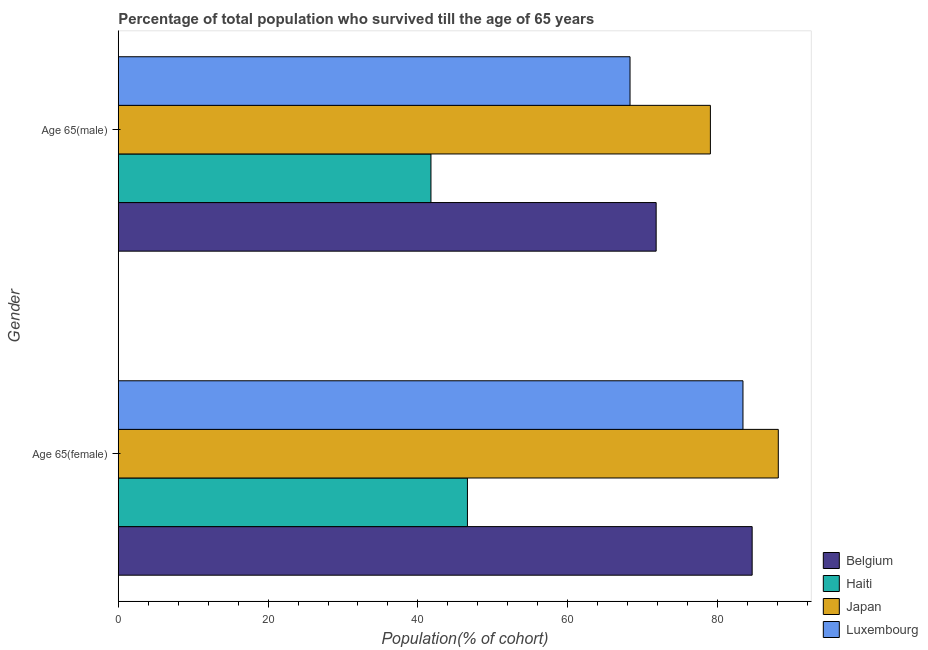How many groups of bars are there?
Your answer should be compact. 2. Are the number of bars per tick equal to the number of legend labels?
Provide a succinct answer. Yes. Are the number of bars on each tick of the Y-axis equal?
Your answer should be very brief. Yes. How many bars are there on the 1st tick from the top?
Your answer should be compact. 4. What is the label of the 2nd group of bars from the top?
Ensure brevity in your answer.  Age 65(female). What is the percentage of female population who survived till age of 65 in Belgium?
Your answer should be compact. 84.63. Across all countries, what is the maximum percentage of male population who survived till age of 65?
Your response must be concise. 79.05. Across all countries, what is the minimum percentage of male population who survived till age of 65?
Provide a succinct answer. 41.74. In which country was the percentage of male population who survived till age of 65 minimum?
Make the answer very short. Haiti. What is the total percentage of female population who survived till age of 65 in the graph?
Your response must be concise. 302.76. What is the difference between the percentage of female population who survived till age of 65 in Haiti and that in Belgium?
Offer a very short reply. -38.01. What is the difference between the percentage of female population who survived till age of 65 in Japan and the percentage of male population who survived till age of 65 in Haiti?
Make the answer very short. 46.37. What is the average percentage of female population who survived till age of 65 per country?
Your response must be concise. 75.69. What is the difference between the percentage of female population who survived till age of 65 and percentage of male population who survived till age of 65 in Belgium?
Keep it short and to the point. 12.82. In how many countries, is the percentage of female population who survived till age of 65 greater than 64 %?
Your answer should be very brief. 3. What is the ratio of the percentage of male population who survived till age of 65 in Belgium to that in Luxembourg?
Make the answer very short. 1.05. Is the percentage of female population who survived till age of 65 in Belgium less than that in Haiti?
Make the answer very short. No. In how many countries, is the percentage of female population who survived till age of 65 greater than the average percentage of female population who survived till age of 65 taken over all countries?
Offer a terse response. 3. What does the 3rd bar from the top in Age 65(male) represents?
Provide a short and direct response. Haiti. What does the 4th bar from the bottom in Age 65(female) represents?
Offer a very short reply. Luxembourg. How many bars are there?
Offer a terse response. 8. Are all the bars in the graph horizontal?
Offer a terse response. Yes. What is the difference between two consecutive major ticks on the X-axis?
Give a very brief answer. 20. Are the values on the major ticks of X-axis written in scientific E-notation?
Provide a succinct answer. No. How many legend labels are there?
Ensure brevity in your answer.  4. How are the legend labels stacked?
Offer a very short reply. Vertical. What is the title of the graph?
Give a very brief answer. Percentage of total population who survived till the age of 65 years. Does "Mauritius" appear as one of the legend labels in the graph?
Make the answer very short. No. What is the label or title of the X-axis?
Your answer should be compact. Population(% of cohort). What is the Population(% of cohort) in Belgium in Age 65(female)?
Your answer should be very brief. 84.63. What is the Population(% of cohort) of Haiti in Age 65(female)?
Offer a very short reply. 46.61. What is the Population(% of cohort) in Japan in Age 65(female)?
Your answer should be compact. 88.12. What is the Population(% of cohort) of Luxembourg in Age 65(female)?
Make the answer very short. 83.4. What is the Population(% of cohort) in Belgium in Age 65(male)?
Offer a terse response. 71.81. What is the Population(% of cohort) in Haiti in Age 65(male)?
Offer a very short reply. 41.74. What is the Population(% of cohort) of Japan in Age 65(male)?
Keep it short and to the point. 79.05. What is the Population(% of cohort) of Luxembourg in Age 65(male)?
Give a very brief answer. 68.32. Across all Gender, what is the maximum Population(% of cohort) in Belgium?
Your answer should be very brief. 84.63. Across all Gender, what is the maximum Population(% of cohort) of Haiti?
Make the answer very short. 46.61. Across all Gender, what is the maximum Population(% of cohort) in Japan?
Offer a very short reply. 88.12. Across all Gender, what is the maximum Population(% of cohort) in Luxembourg?
Keep it short and to the point. 83.4. Across all Gender, what is the minimum Population(% of cohort) in Belgium?
Give a very brief answer. 71.81. Across all Gender, what is the minimum Population(% of cohort) of Haiti?
Provide a short and direct response. 41.74. Across all Gender, what is the minimum Population(% of cohort) of Japan?
Your answer should be compact. 79.05. Across all Gender, what is the minimum Population(% of cohort) in Luxembourg?
Ensure brevity in your answer.  68.32. What is the total Population(% of cohort) in Belgium in the graph?
Your answer should be very brief. 156.44. What is the total Population(% of cohort) of Haiti in the graph?
Ensure brevity in your answer.  88.36. What is the total Population(% of cohort) in Japan in the graph?
Offer a very short reply. 167.17. What is the total Population(% of cohort) of Luxembourg in the graph?
Offer a very short reply. 151.72. What is the difference between the Population(% of cohort) of Belgium in Age 65(female) and that in Age 65(male)?
Offer a terse response. 12.82. What is the difference between the Population(% of cohort) of Haiti in Age 65(female) and that in Age 65(male)?
Provide a succinct answer. 4.87. What is the difference between the Population(% of cohort) of Japan in Age 65(female) and that in Age 65(male)?
Provide a succinct answer. 9.07. What is the difference between the Population(% of cohort) of Luxembourg in Age 65(female) and that in Age 65(male)?
Provide a succinct answer. 15.08. What is the difference between the Population(% of cohort) of Belgium in Age 65(female) and the Population(% of cohort) of Haiti in Age 65(male)?
Keep it short and to the point. 42.88. What is the difference between the Population(% of cohort) in Belgium in Age 65(female) and the Population(% of cohort) in Japan in Age 65(male)?
Make the answer very short. 5.58. What is the difference between the Population(% of cohort) in Belgium in Age 65(female) and the Population(% of cohort) in Luxembourg in Age 65(male)?
Keep it short and to the point. 16.3. What is the difference between the Population(% of cohort) of Haiti in Age 65(female) and the Population(% of cohort) of Japan in Age 65(male)?
Ensure brevity in your answer.  -32.44. What is the difference between the Population(% of cohort) in Haiti in Age 65(female) and the Population(% of cohort) in Luxembourg in Age 65(male)?
Offer a very short reply. -21.71. What is the difference between the Population(% of cohort) of Japan in Age 65(female) and the Population(% of cohort) of Luxembourg in Age 65(male)?
Your response must be concise. 19.8. What is the average Population(% of cohort) in Belgium per Gender?
Your answer should be very brief. 78.22. What is the average Population(% of cohort) of Haiti per Gender?
Offer a terse response. 44.18. What is the average Population(% of cohort) of Japan per Gender?
Offer a very short reply. 83.58. What is the average Population(% of cohort) of Luxembourg per Gender?
Provide a short and direct response. 75.86. What is the difference between the Population(% of cohort) of Belgium and Population(% of cohort) of Haiti in Age 65(female)?
Provide a short and direct response. 38.01. What is the difference between the Population(% of cohort) of Belgium and Population(% of cohort) of Japan in Age 65(female)?
Offer a terse response. -3.49. What is the difference between the Population(% of cohort) of Belgium and Population(% of cohort) of Luxembourg in Age 65(female)?
Provide a short and direct response. 1.23. What is the difference between the Population(% of cohort) of Haiti and Population(% of cohort) of Japan in Age 65(female)?
Give a very brief answer. -41.5. What is the difference between the Population(% of cohort) of Haiti and Population(% of cohort) of Luxembourg in Age 65(female)?
Keep it short and to the point. -36.79. What is the difference between the Population(% of cohort) of Japan and Population(% of cohort) of Luxembourg in Age 65(female)?
Offer a terse response. 4.72. What is the difference between the Population(% of cohort) of Belgium and Population(% of cohort) of Haiti in Age 65(male)?
Your answer should be very brief. 30.07. What is the difference between the Population(% of cohort) in Belgium and Population(% of cohort) in Japan in Age 65(male)?
Offer a terse response. -7.24. What is the difference between the Population(% of cohort) in Belgium and Population(% of cohort) in Luxembourg in Age 65(male)?
Provide a succinct answer. 3.49. What is the difference between the Population(% of cohort) of Haiti and Population(% of cohort) of Japan in Age 65(male)?
Provide a succinct answer. -37.31. What is the difference between the Population(% of cohort) in Haiti and Population(% of cohort) in Luxembourg in Age 65(male)?
Keep it short and to the point. -26.58. What is the difference between the Population(% of cohort) in Japan and Population(% of cohort) in Luxembourg in Age 65(male)?
Provide a succinct answer. 10.73. What is the ratio of the Population(% of cohort) in Belgium in Age 65(female) to that in Age 65(male)?
Your response must be concise. 1.18. What is the ratio of the Population(% of cohort) in Haiti in Age 65(female) to that in Age 65(male)?
Give a very brief answer. 1.12. What is the ratio of the Population(% of cohort) in Japan in Age 65(female) to that in Age 65(male)?
Provide a succinct answer. 1.11. What is the ratio of the Population(% of cohort) of Luxembourg in Age 65(female) to that in Age 65(male)?
Provide a succinct answer. 1.22. What is the difference between the highest and the second highest Population(% of cohort) in Belgium?
Provide a short and direct response. 12.82. What is the difference between the highest and the second highest Population(% of cohort) of Haiti?
Offer a very short reply. 4.87. What is the difference between the highest and the second highest Population(% of cohort) in Japan?
Make the answer very short. 9.07. What is the difference between the highest and the second highest Population(% of cohort) in Luxembourg?
Give a very brief answer. 15.08. What is the difference between the highest and the lowest Population(% of cohort) in Belgium?
Provide a succinct answer. 12.82. What is the difference between the highest and the lowest Population(% of cohort) in Haiti?
Your answer should be compact. 4.87. What is the difference between the highest and the lowest Population(% of cohort) of Japan?
Ensure brevity in your answer.  9.07. What is the difference between the highest and the lowest Population(% of cohort) of Luxembourg?
Make the answer very short. 15.08. 